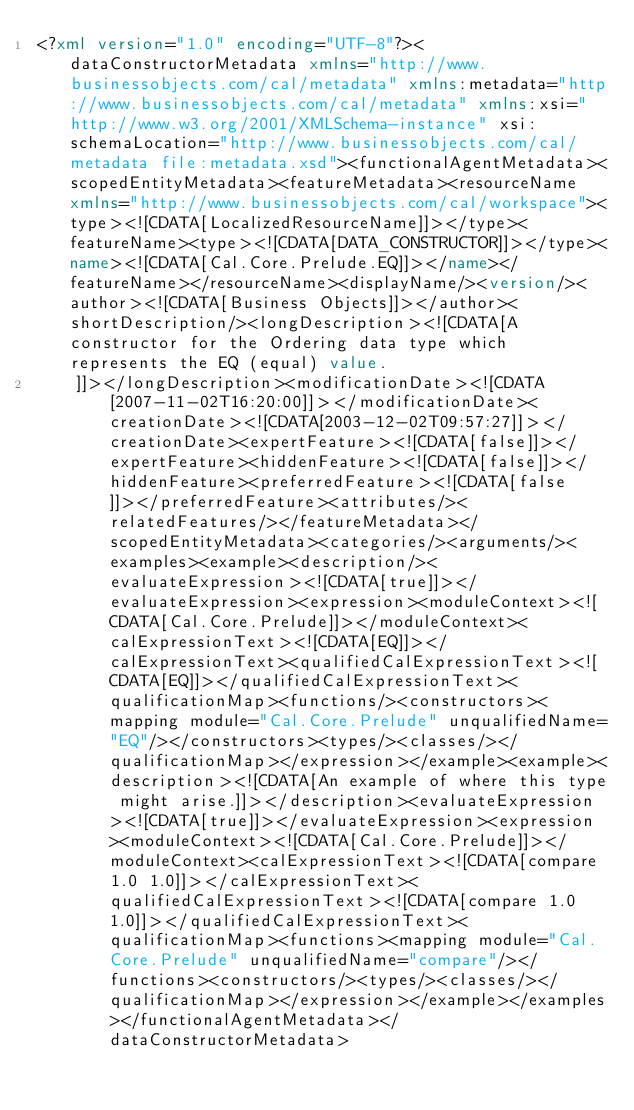<code> <loc_0><loc_0><loc_500><loc_500><_XML_><?xml version="1.0" encoding="UTF-8"?><dataConstructorMetadata xmlns="http://www.businessobjects.com/cal/metadata" xmlns:metadata="http://www.businessobjects.com/cal/metadata" xmlns:xsi="http://www.w3.org/2001/XMLSchema-instance" xsi:schemaLocation="http://www.businessobjects.com/cal/metadata file:metadata.xsd"><functionalAgentMetadata><scopedEntityMetadata><featureMetadata><resourceName xmlns="http://www.businessobjects.com/cal/workspace"><type><![CDATA[LocalizedResourceName]]></type><featureName><type><![CDATA[DATA_CONSTRUCTOR]]></type><name><![CDATA[Cal.Core.Prelude.EQ]]></name></featureName></resourceName><displayName/><version/><author><![CDATA[Business Objects]]></author><shortDescription/><longDescription><![CDATA[A constructor for the Ordering data type which represents the EQ (equal) value.
		]]></longDescription><modificationDate><![CDATA[2007-11-02T16:20:00]]></modificationDate><creationDate><![CDATA[2003-12-02T09:57:27]]></creationDate><expertFeature><![CDATA[false]]></expertFeature><hiddenFeature><![CDATA[false]]></hiddenFeature><preferredFeature><![CDATA[false]]></preferredFeature><attributes/><relatedFeatures/></featureMetadata></scopedEntityMetadata><categories/><arguments/><examples><example><description/><evaluateExpression><![CDATA[true]]></evaluateExpression><expression><moduleContext><![CDATA[Cal.Core.Prelude]]></moduleContext><calExpressionText><![CDATA[EQ]]></calExpressionText><qualifiedCalExpressionText><![CDATA[EQ]]></qualifiedCalExpressionText><qualificationMap><functions/><constructors><mapping module="Cal.Core.Prelude" unqualifiedName="EQ"/></constructors><types/><classes/></qualificationMap></expression></example><example><description><![CDATA[An example of where this type might arise.]]></description><evaluateExpression><![CDATA[true]]></evaluateExpression><expression><moduleContext><![CDATA[Cal.Core.Prelude]]></moduleContext><calExpressionText><![CDATA[compare 1.0 1.0]]></calExpressionText><qualifiedCalExpressionText><![CDATA[compare 1.0 1.0]]></qualifiedCalExpressionText><qualificationMap><functions><mapping module="Cal.Core.Prelude" unqualifiedName="compare"/></functions><constructors/><types/><classes/></qualificationMap></expression></example></examples></functionalAgentMetadata></dataConstructorMetadata></code> 